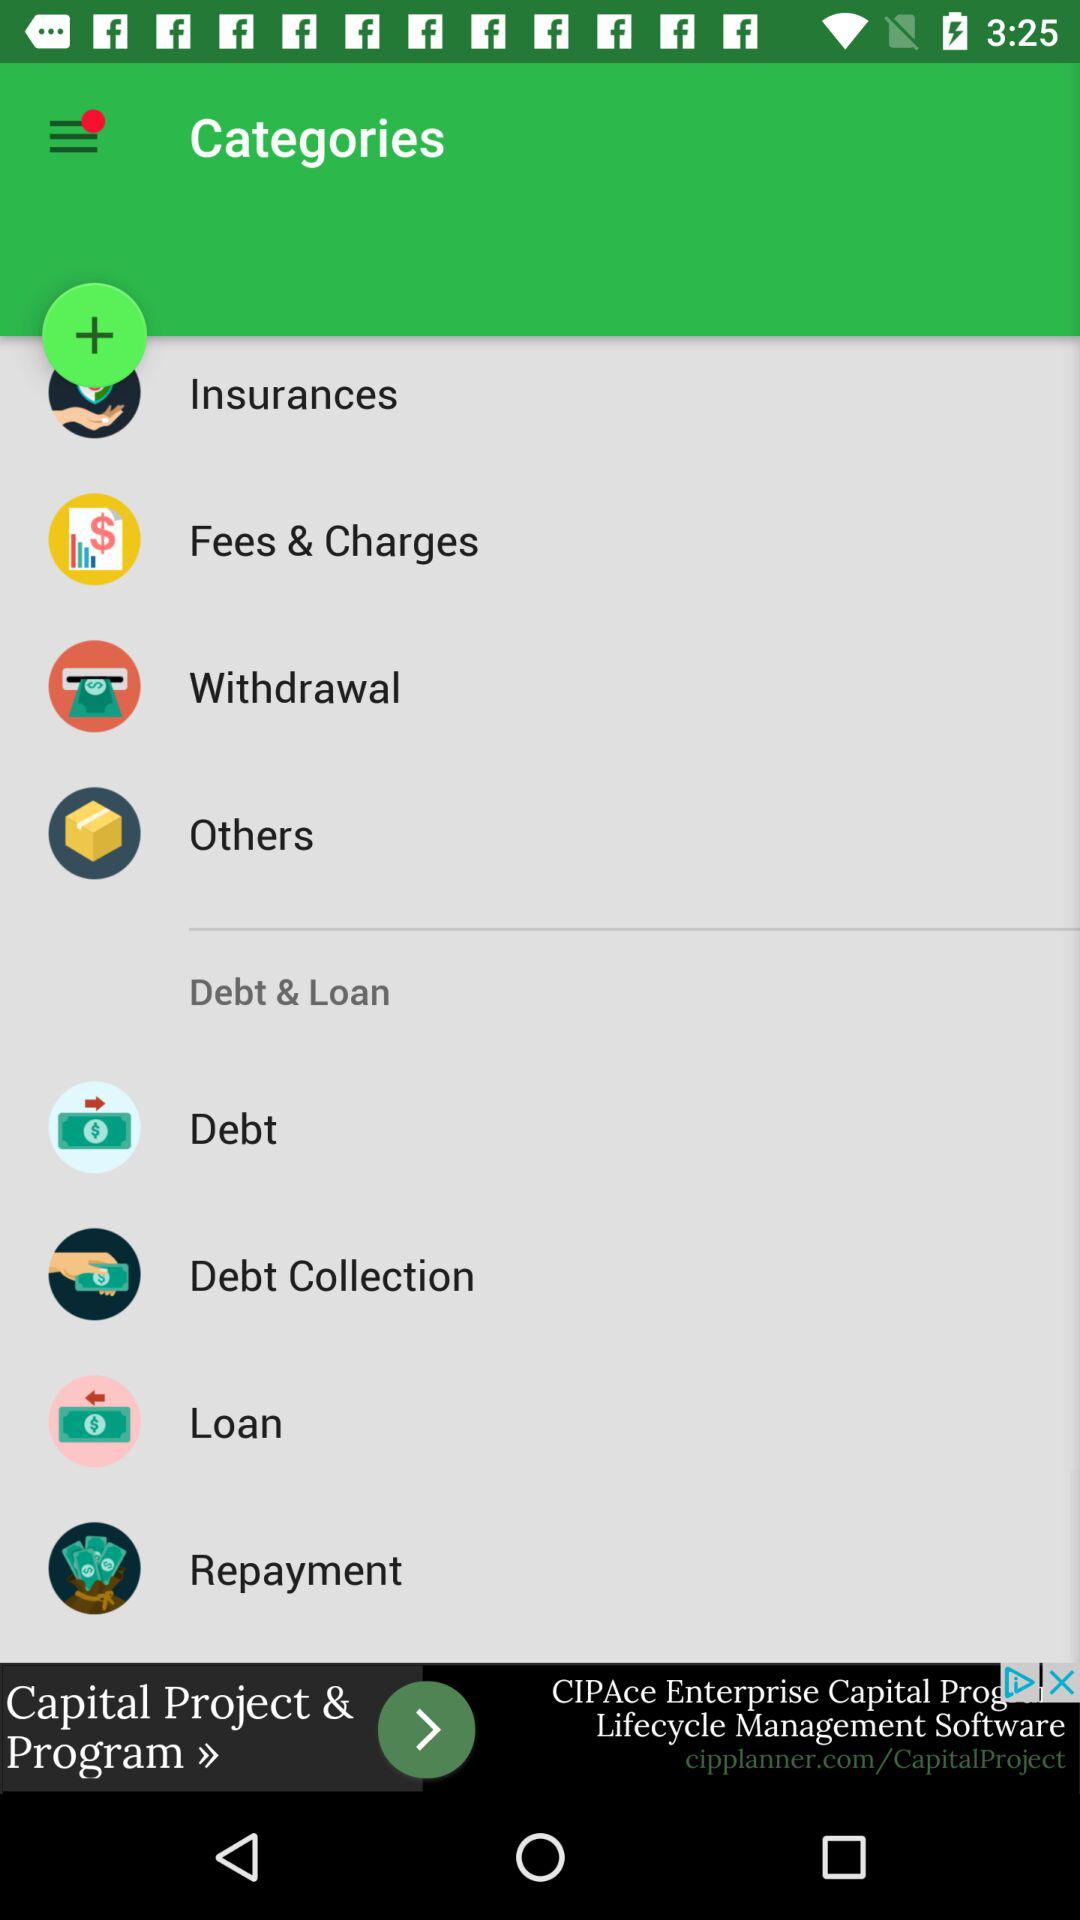How many items are in the Debt & Loan category?
Answer the question using a single word or phrase. 4 